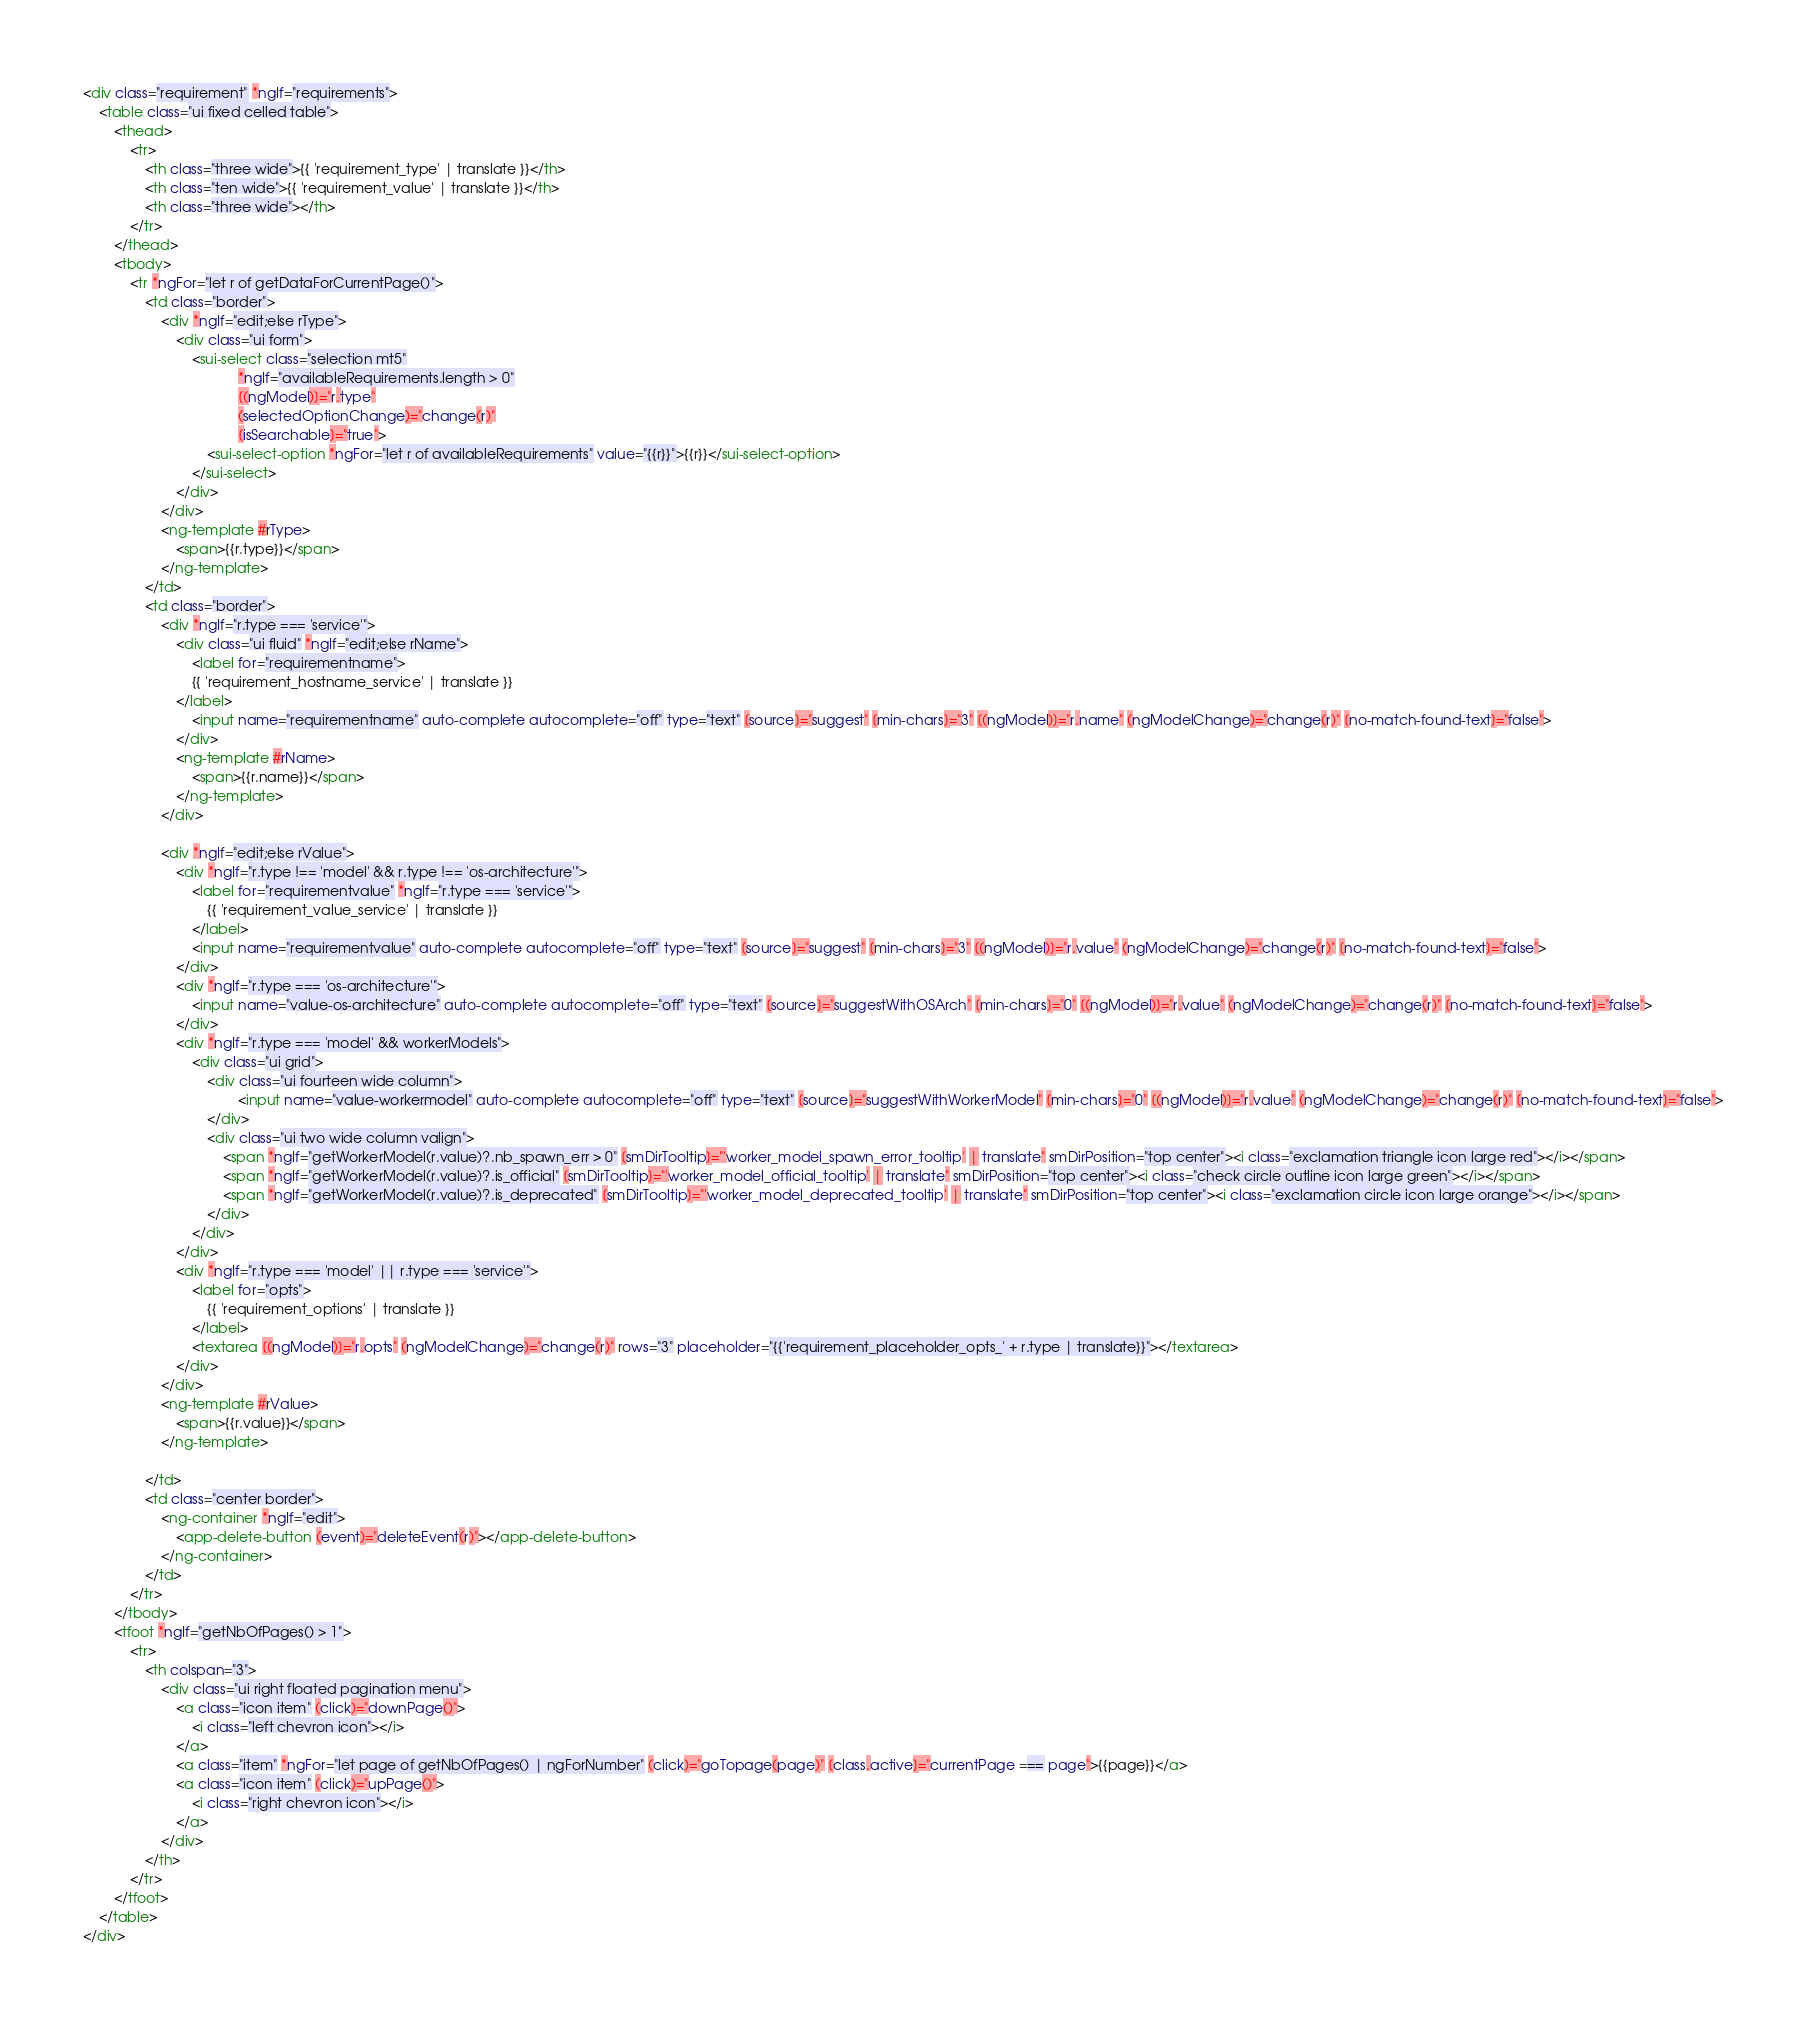Convert code to text. <code><loc_0><loc_0><loc_500><loc_500><_HTML_><div class="requirement" *ngIf="requirements">
    <table class="ui fixed celled table">
        <thead>
            <tr>
                <th class="three wide">{{ 'requirement_type' | translate }}</th>
                <th class="ten wide">{{ 'requirement_value' | translate }}</th>
                <th class="three wide"></th>
            </tr>
        </thead>
        <tbody>
            <tr *ngFor="let r of getDataForCurrentPage()">
                <td class="border">
                    <div *ngIf="edit;else rType">
                        <div class="ui form">
                            <sui-select class="selection mt5"
                                        *ngIf="availableRequirements.length > 0"
                                        [(ngModel)]="r.type"
                                        (selectedOptionChange)="change(r)"
                                        [isSearchable]="true">
                                <sui-select-option *ngFor="let r of availableRequirements" value="{{r}}">{{r}}</sui-select-option>
                            </sui-select>
                        </div>
                    </div>
                    <ng-template #rType>
                        <span>{{r.type}}</span>
                    </ng-template>
                </td>
                <td class="border">
                    <div *ngIf="r.type === 'service'">
                        <div class="ui fluid" *ngIf="edit;else rName">
                            <label for="requirementname">
                            {{ 'requirement_hostname_service' | translate }}
                        </label>
                            <input name="requirementname" auto-complete autocomplete="off" type="text" [source]="suggest" [min-chars]="3" [(ngModel)]="r.name" (ngModelChange)="change(r)" [no-match-found-text]="false">
                        </div>
                        <ng-template #rName>
                            <span>{{r.name}}</span>
                        </ng-template>
                    </div>

                    <div *ngIf="edit;else rValue">
                        <div *ngIf="r.type !== 'model' && r.type !== 'os-architecture'">
                            <label for="requirementvalue" *ngIf="r.type === 'service'">
                                {{ 'requirement_value_service' | translate }}
                            </label>
                            <input name="requirementvalue" auto-complete autocomplete="off" type="text" [source]="suggest" [min-chars]="3" [(ngModel)]="r.value" (ngModelChange)="change(r)" [no-match-found-text]="false">
                        </div>
                        <div *ngIf="r.type === 'os-architecture'">
                            <input name="value-os-architecture" auto-complete autocomplete="off" type="text" [source]="suggestWithOSArch" [min-chars]="0" [(ngModel)]="r.value" (ngModelChange)="change(r)" [no-match-found-text]="false">
                        </div>
                        <div *ngIf="r.type === 'model' && workerModels">
                            <div class="ui grid">
                                <div class="ui fourteen wide column">
                                        <input name="value-workermodel" auto-complete autocomplete="off" type="text" [source]="suggestWithWorkerModel" [min-chars]="0" [(ngModel)]="r.value" (ngModelChange)="change(r)" [no-match-found-text]="false">
                                </div>
                                <div class="ui two wide column valign">
                                    <span *ngIf="getWorkerModel(r.value)?.nb_spawn_err > 0" [smDirTooltip]="'worker_model_spawn_error_tooltip' | translate" smDirPosition="top center"><i class="exclamation triangle icon large red"></i></span>
                                    <span *ngIf="getWorkerModel(r.value)?.is_official" [smDirTooltip]="'worker_model_official_tooltip' | translate" smDirPosition="top center"><i class="check circle outline icon large green"></i></span>
                                    <span *ngIf="getWorkerModel(r.value)?.is_deprecated" [smDirTooltip]="'worker_model_deprecated_tooltip' | translate" smDirPosition="top center"><i class="exclamation circle icon large orange"></i></span>
                                </div>
                            </div>
                        </div>
                        <div *ngIf="r.type === 'model' || r.type === 'service'">
                            <label for="opts">
                                {{ 'requirement_options' | translate }}
                            </label>
                            <textarea [(ngModel)]="r.opts" (ngModelChange)="change(r)" rows="3" placeholder="{{'requirement_placeholder_opts_' + r.type | translate}}"></textarea>
                        </div>
                    </div>
                    <ng-template #rValue>
                        <span>{{r.value}}</span>
                    </ng-template>

                </td>
                <td class="center border">
                    <ng-container *ngIf="edit">
                        <app-delete-button (event)="deleteEvent(r)"></app-delete-button>
                    </ng-container>
                </td>
            </tr>
        </tbody>
        <tfoot *ngIf="getNbOfPages() > 1">
            <tr>
                <th colspan="3">
                    <div class="ui right floated pagination menu">
                        <a class="icon item" (click)="downPage()">
                            <i class="left chevron icon"></i>
                        </a>
                        <a class="item" *ngFor="let page of getNbOfPages() | ngForNumber" (click)="goTopage(page)" [class.active]="currentPage === page">{{page}}</a>
                        <a class="icon item" (click)="upPage()">
                            <i class="right chevron icon"></i>
                        </a>
                    </div>
                </th>
            </tr>
        </tfoot>
    </table>
</div>
</code> 